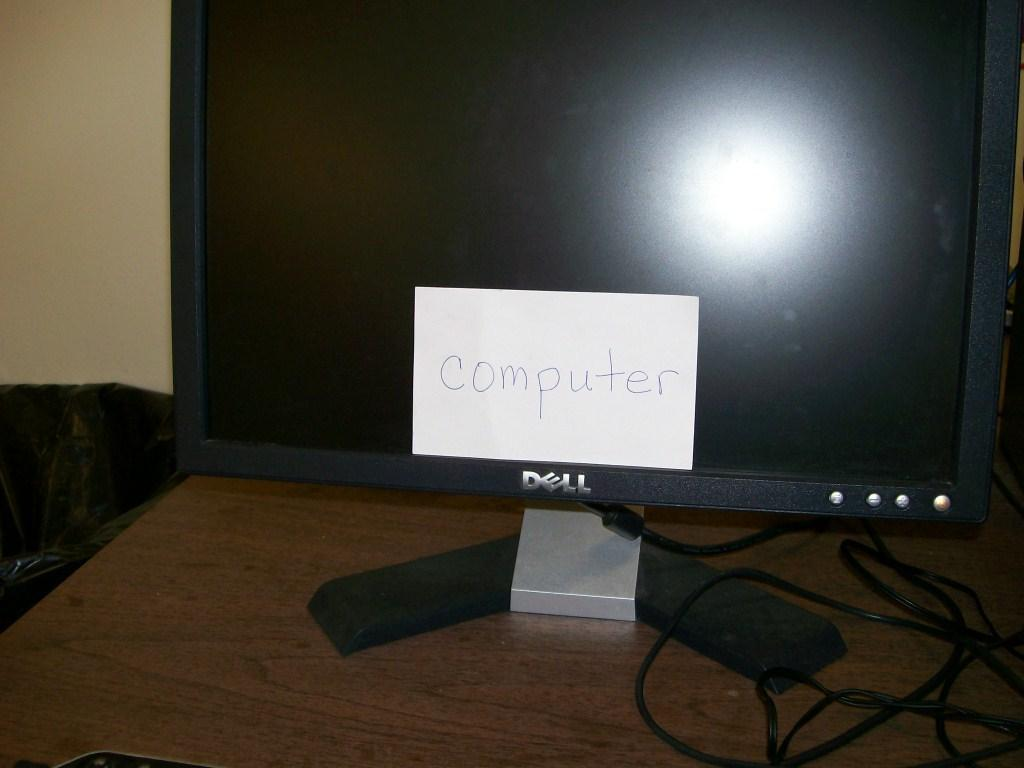What electronic device is present in the image? There is a monitor in the image. Where is the monitor located? The monitor is on a table. What is placed on top of the monitor? There is a paper on the monitor. What else can be seen in the image besides the monitor and paper? Cables are visible in the image. How many bottles are visible on the monitor in the image? There are no bottles present on the monitor or in the image. 